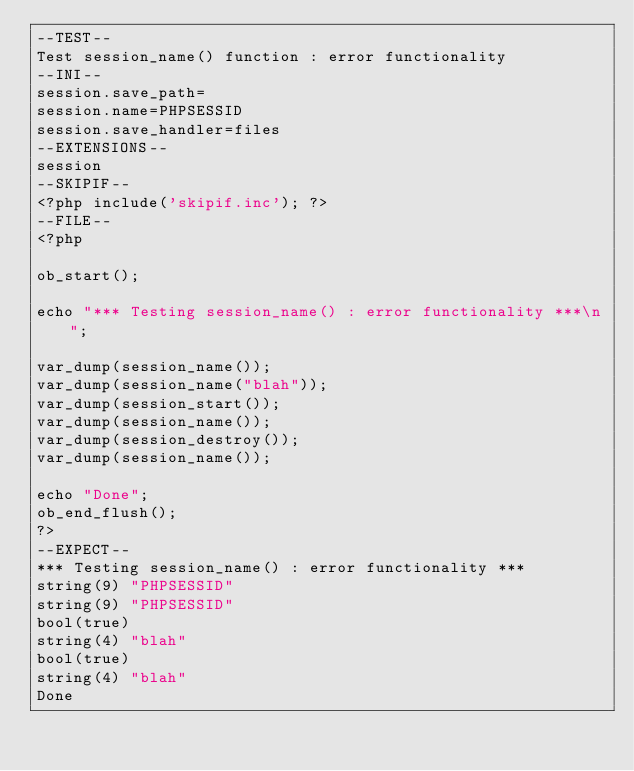<code> <loc_0><loc_0><loc_500><loc_500><_PHP_>--TEST--
Test session_name() function : error functionality
--INI--
session.save_path=
session.name=PHPSESSID
session.save_handler=files
--EXTENSIONS--
session
--SKIPIF--
<?php include('skipif.inc'); ?>
--FILE--
<?php

ob_start();

echo "*** Testing session_name() : error functionality ***\n";

var_dump(session_name());
var_dump(session_name("blah"));
var_dump(session_start());
var_dump(session_name());
var_dump(session_destroy());
var_dump(session_name());

echo "Done";
ob_end_flush();
?>
--EXPECT--
*** Testing session_name() : error functionality ***
string(9) "PHPSESSID"
string(9) "PHPSESSID"
bool(true)
string(4) "blah"
bool(true)
string(4) "blah"
Done
</code> 